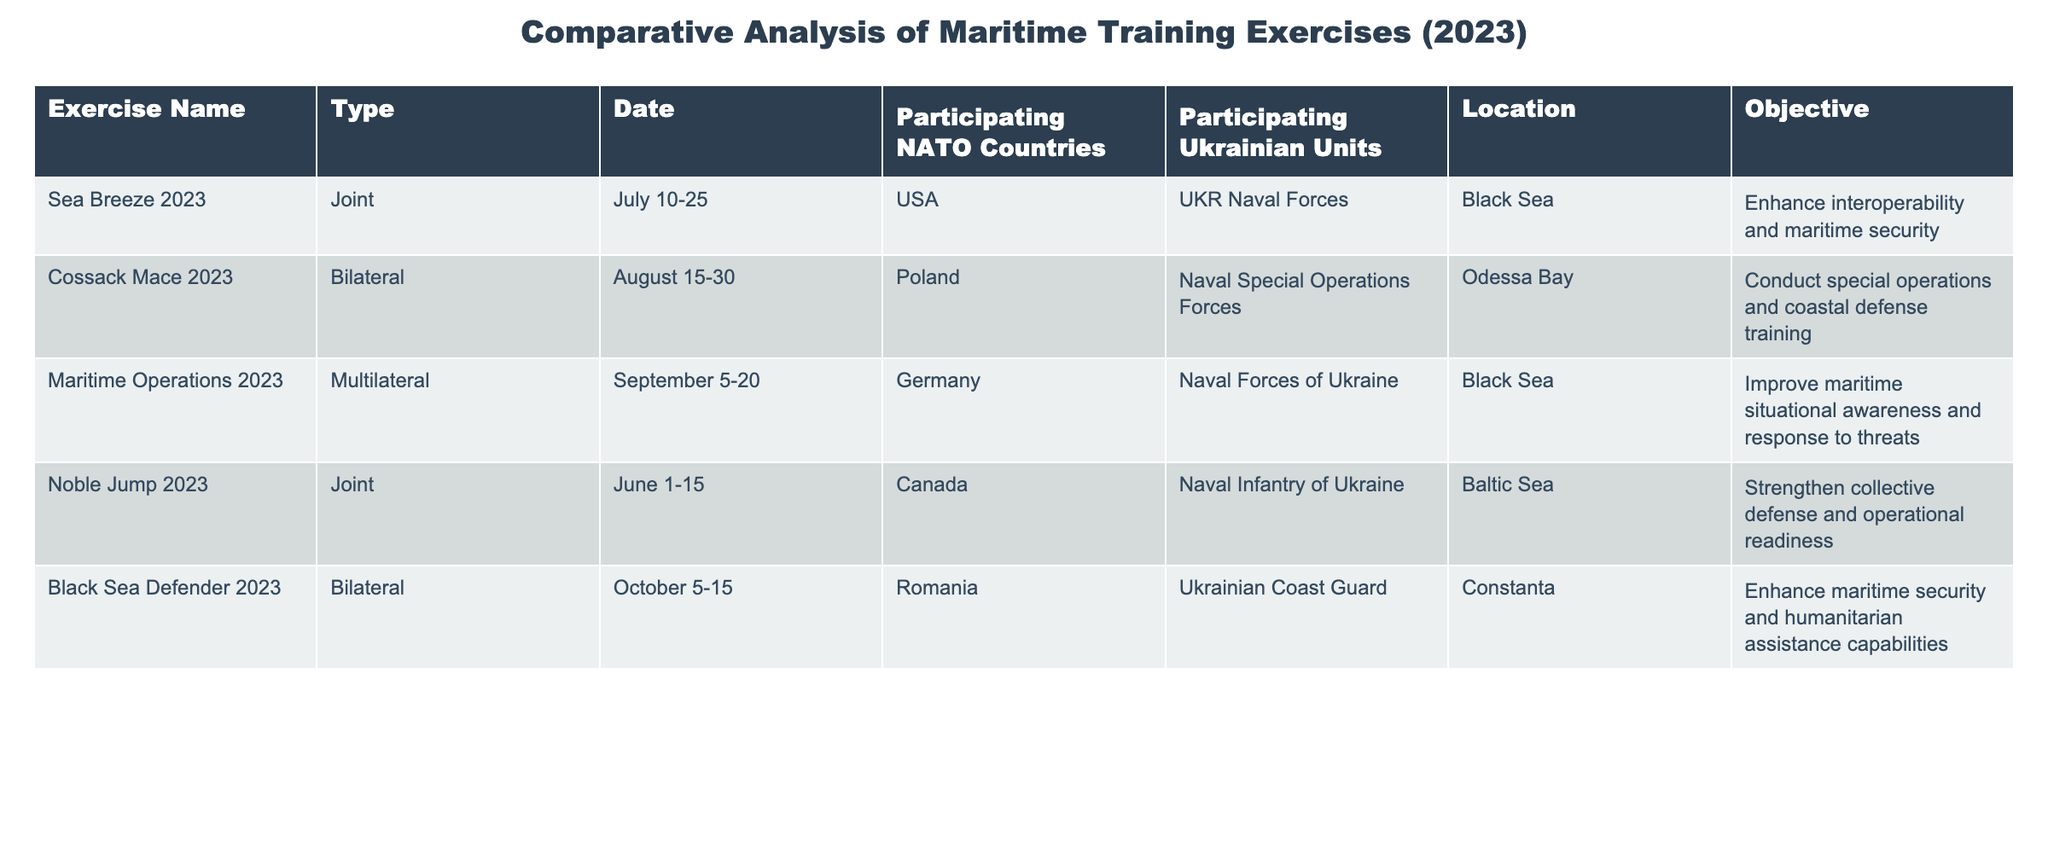What is the name of the exercise conducted in the Black Sea in July 2023? The table lists the exercises along with their details. The exercise conducted in the Black Sea in July 2023 is "Sea Breeze 2023."
Answer: Sea Breeze 2023 How many NATO countries participated in the "Noble Jump 2023" exercise? Looking at the row for "Noble Jump 2023," it shows that Canada was the participating NATO country in this joint exercise. Therefore, the total count is one.
Answer: 1 What is the main objective of the "Cossack Mace 2023" exercise? The table indicates that the main objective of "Cossack Mace 2023" is to conduct special operations and coastal defense training, as listed in the objectives column.
Answer: Conduct special operations and coastal defense training How many total exercises listed were conducted in the Black Sea? Counting the rows, "Sea Breeze 2023" and "Maritime Operations 2023" were both conducted in the Black Sea, giving us a total of two exercises in this location.
Answer: 2 Is "Black Sea Defender 2023" a bilateral exercise? The table shows that "Black Sea Defender 2023" is categorized as a bilateral exercise, as specified under the 'Type' column.
Answer: Yes What is the average duration of the exercises listed in the table? The durations are: Sea Breeze (15 days), Cossack Mace (15 days), Maritime Operations (15 days), Noble Jump (15 days), and Black Sea Defender (10 days). Summing these gives 15 + 15 + 15 + 15 + 10 = 70 days and dividing by 5 gives an average of 14 days.
Answer: 14 days Which Ukrainian unit participated in the "Maritime Operations 2023" exercise? The row for "Maritime Operations 2023" indicates that the participating Ukrainian unit is the Naval Forces of Ukraine.
Answer: Naval Forces of Ukraine Which two exercises aim to enhance maritime security? The exercises "Black Sea Defender 2023" and "Sea Breeze 2023" both have objectives related to enhancing maritime security, as stated in the objectives column.
Answer: Black Sea Defender 2023 and Sea Breeze 2023 How many multilateral exercises were conducted according to the table? The table shows only one multilateral exercise labeled "Maritime Operations 2023," thus giving a total count of one multilateral exercise.
Answer: 1 